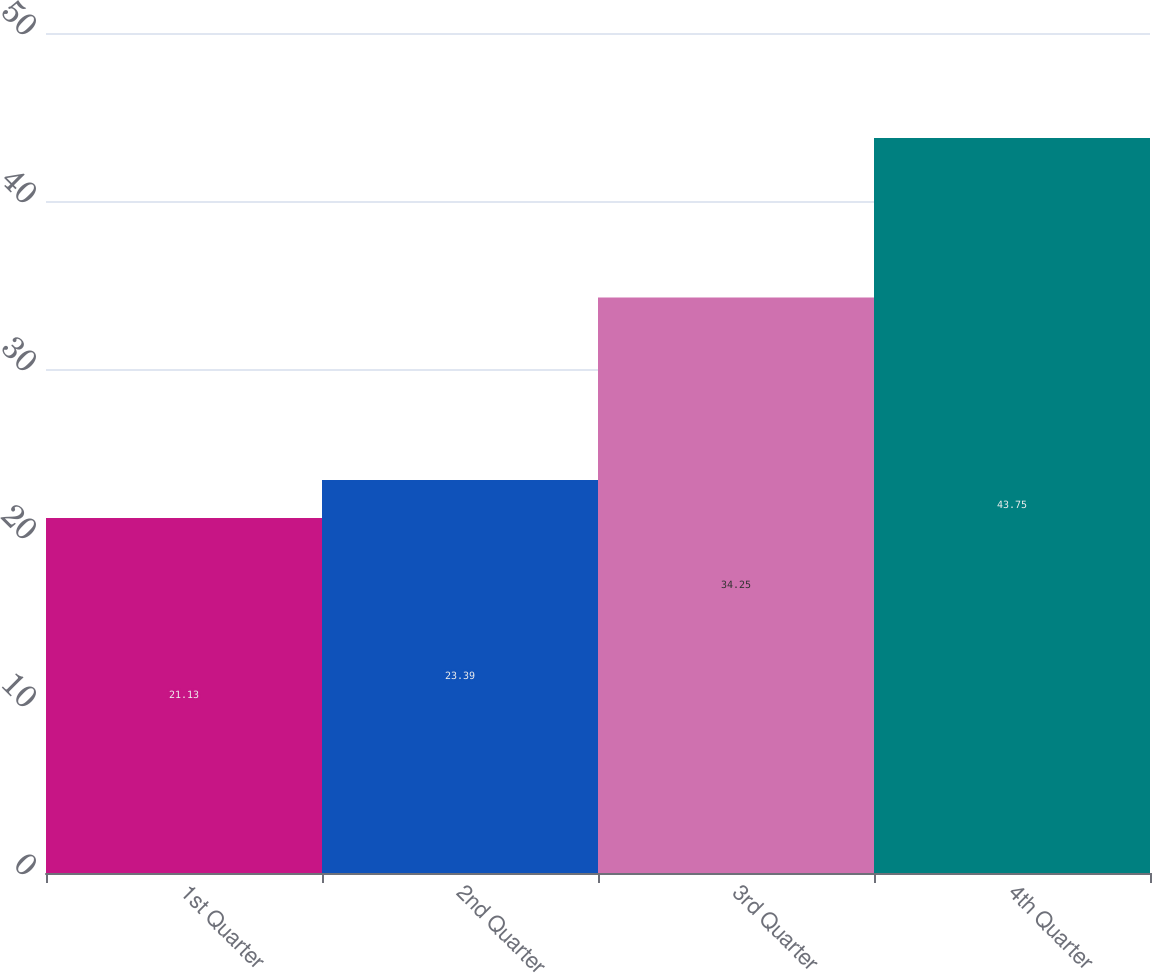Convert chart. <chart><loc_0><loc_0><loc_500><loc_500><bar_chart><fcel>1st Quarter<fcel>2nd Quarter<fcel>3rd Quarter<fcel>4th Quarter<nl><fcel>21.13<fcel>23.39<fcel>34.25<fcel>43.75<nl></chart> 